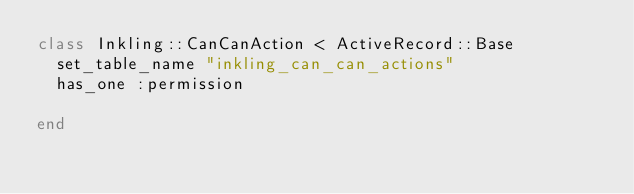<code> <loc_0><loc_0><loc_500><loc_500><_Ruby_>class Inkling::CanCanAction < ActiveRecord::Base
  set_table_name "inkling_can_can_actions"
  has_one :permission
  
end</code> 